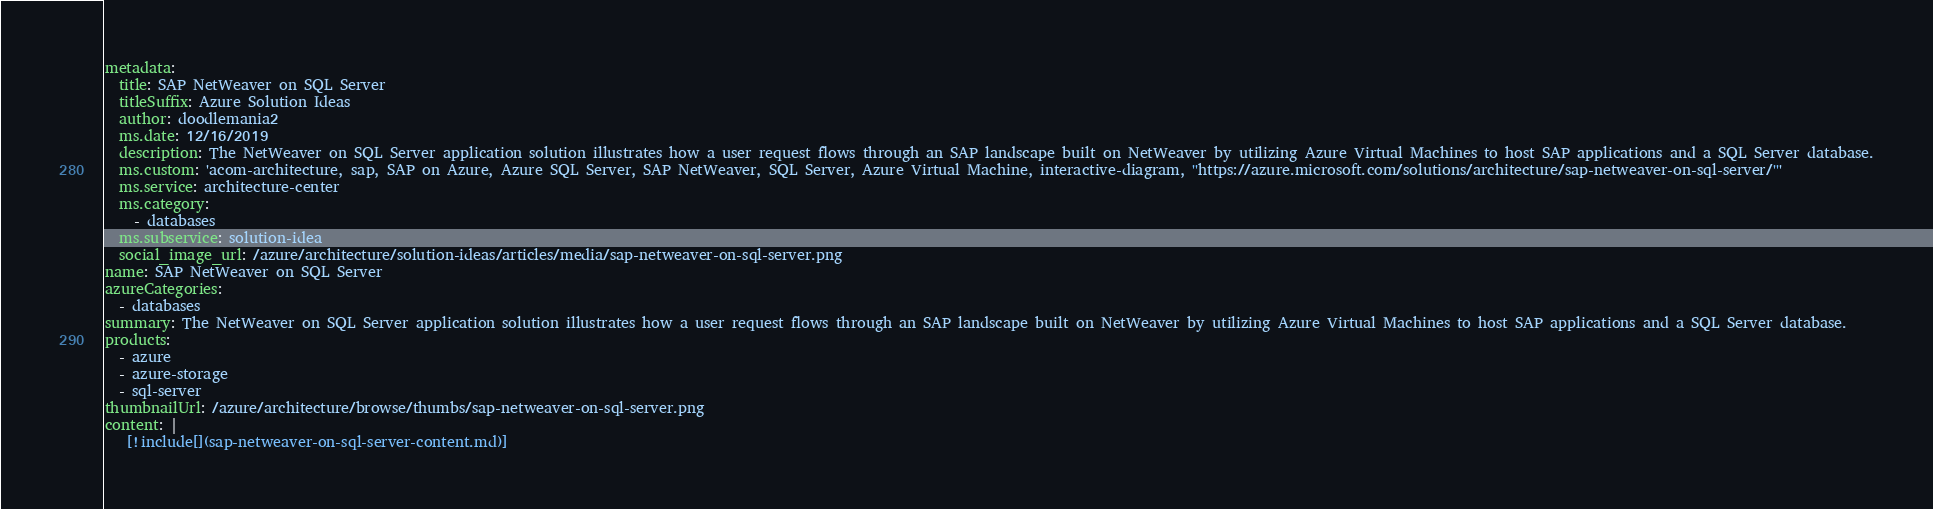<code> <loc_0><loc_0><loc_500><loc_500><_YAML_>metadata:
  title: SAP NetWeaver on SQL Server
  titleSuffix: Azure Solution Ideas
  author: doodlemania2
  ms.date: 12/16/2019
  description: The NetWeaver on SQL Server application solution illustrates how a user request flows through an SAP landscape built on NetWeaver by utilizing Azure Virtual Machines to host SAP applications and a SQL Server database.
  ms.custom: 'acom-architecture, sap, SAP on Azure, Azure SQL Server, SAP NetWeaver, SQL Server, Azure Virtual Machine, interactive-diagram, ''https://azure.microsoft.com/solutions/architecture/sap-netweaver-on-sql-server/'''
  ms.service: architecture-center
  ms.category:
    - databases
  ms.subservice: solution-idea
  social_image_url: /azure/architecture/solution-ideas/articles/media/sap-netweaver-on-sql-server.png
name: SAP NetWeaver on SQL Server
azureCategories:
  - databases
summary: The NetWeaver on SQL Server application solution illustrates how a user request flows through an SAP landscape built on NetWeaver by utilizing Azure Virtual Machines to host SAP applications and a SQL Server database.
products:
  - azure
  - azure-storage
  - sql-server
thumbnailUrl: /azure/architecture/browse/thumbs/sap-netweaver-on-sql-server.png
content: |
   [!include[](sap-netweaver-on-sql-server-content.md)]
</code> 